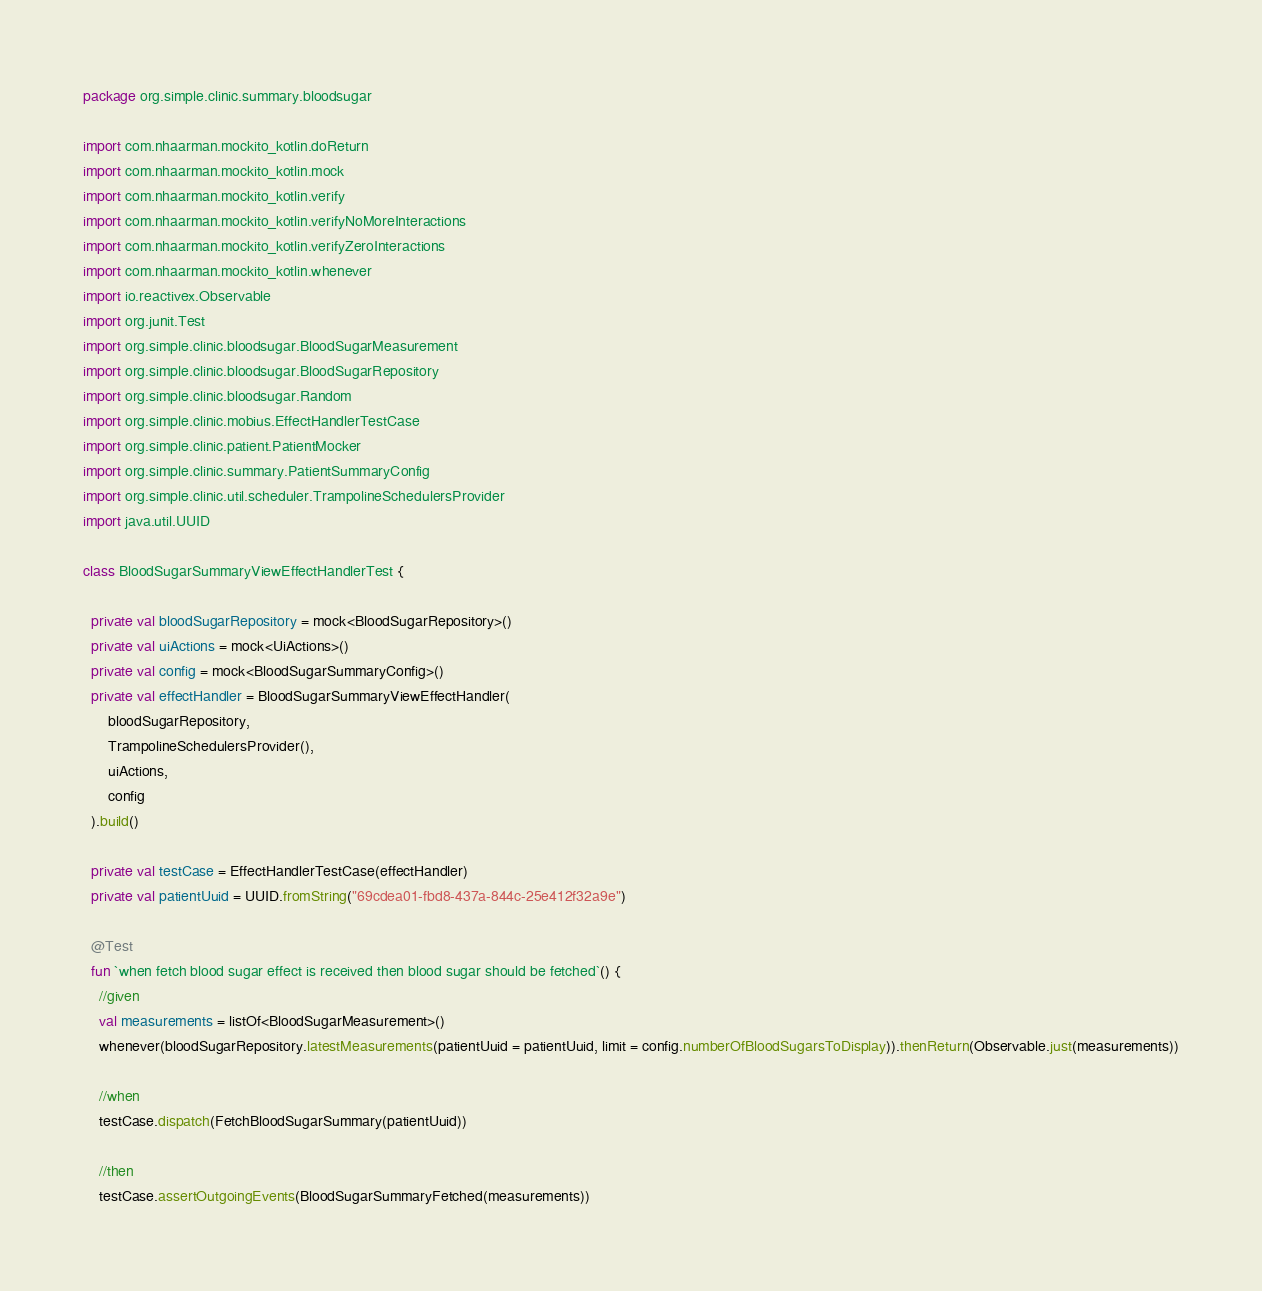<code> <loc_0><loc_0><loc_500><loc_500><_Kotlin_>package org.simple.clinic.summary.bloodsugar

import com.nhaarman.mockito_kotlin.doReturn
import com.nhaarman.mockito_kotlin.mock
import com.nhaarman.mockito_kotlin.verify
import com.nhaarman.mockito_kotlin.verifyNoMoreInteractions
import com.nhaarman.mockito_kotlin.verifyZeroInteractions
import com.nhaarman.mockito_kotlin.whenever
import io.reactivex.Observable
import org.junit.Test
import org.simple.clinic.bloodsugar.BloodSugarMeasurement
import org.simple.clinic.bloodsugar.BloodSugarRepository
import org.simple.clinic.bloodsugar.Random
import org.simple.clinic.mobius.EffectHandlerTestCase
import org.simple.clinic.patient.PatientMocker
import org.simple.clinic.summary.PatientSummaryConfig
import org.simple.clinic.util.scheduler.TrampolineSchedulersProvider
import java.util.UUID

class BloodSugarSummaryViewEffectHandlerTest {

  private val bloodSugarRepository = mock<BloodSugarRepository>()
  private val uiActions = mock<UiActions>()
  private val config = mock<BloodSugarSummaryConfig>()
  private val effectHandler = BloodSugarSummaryViewEffectHandler(
      bloodSugarRepository,
      TrampolineSchedulersProvider(),
      uiActions,
      config
  ).build()

  private val testCase = EffectHandlerTestCase(effectHandler)
  private val patientUuid = UUID.fromString("69cdea01-fbd8-437a-844c-25e412f32a9e")

  @Test
  fun `when fetch blood sugar effect is received then blood sugar should be fetched`() {
    //given
    val measurements = listOf<BloodSugarMeasurement>()
    whenever(bloodSugarRepository.latestMeasurements(patientUuid = patientUuid, limit = config.numberOfBloodSugarsToDisplay)).thenReturn(Observable.just(measurements))

    //when
    testCase.dispatch(FetchBloodSugarSummary(patientUuid))

    //then
    testCase.assertOutgoingEvents(BloodSugarSummaryFetched(measurements))</code> 